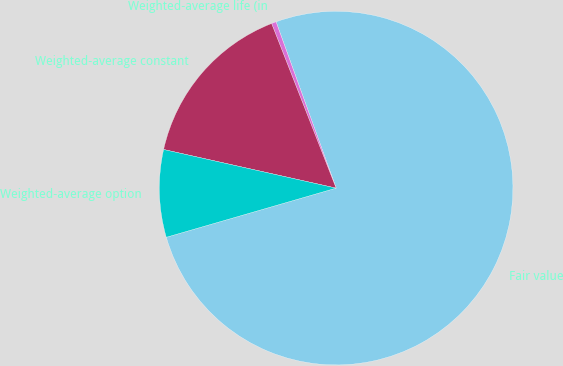Convert chart. <chart><loc_0><loc_0><loc_500><loc_500><pie_chart><fcel>Fair value<fcel>Weighted-average life (in<fcel>Weighted-average constant<fcel>Weighted-average option<nl><fcel>76.04%<fcel>0.43%<fcel>15.55%<fcel>7.99%<nl></chart> 